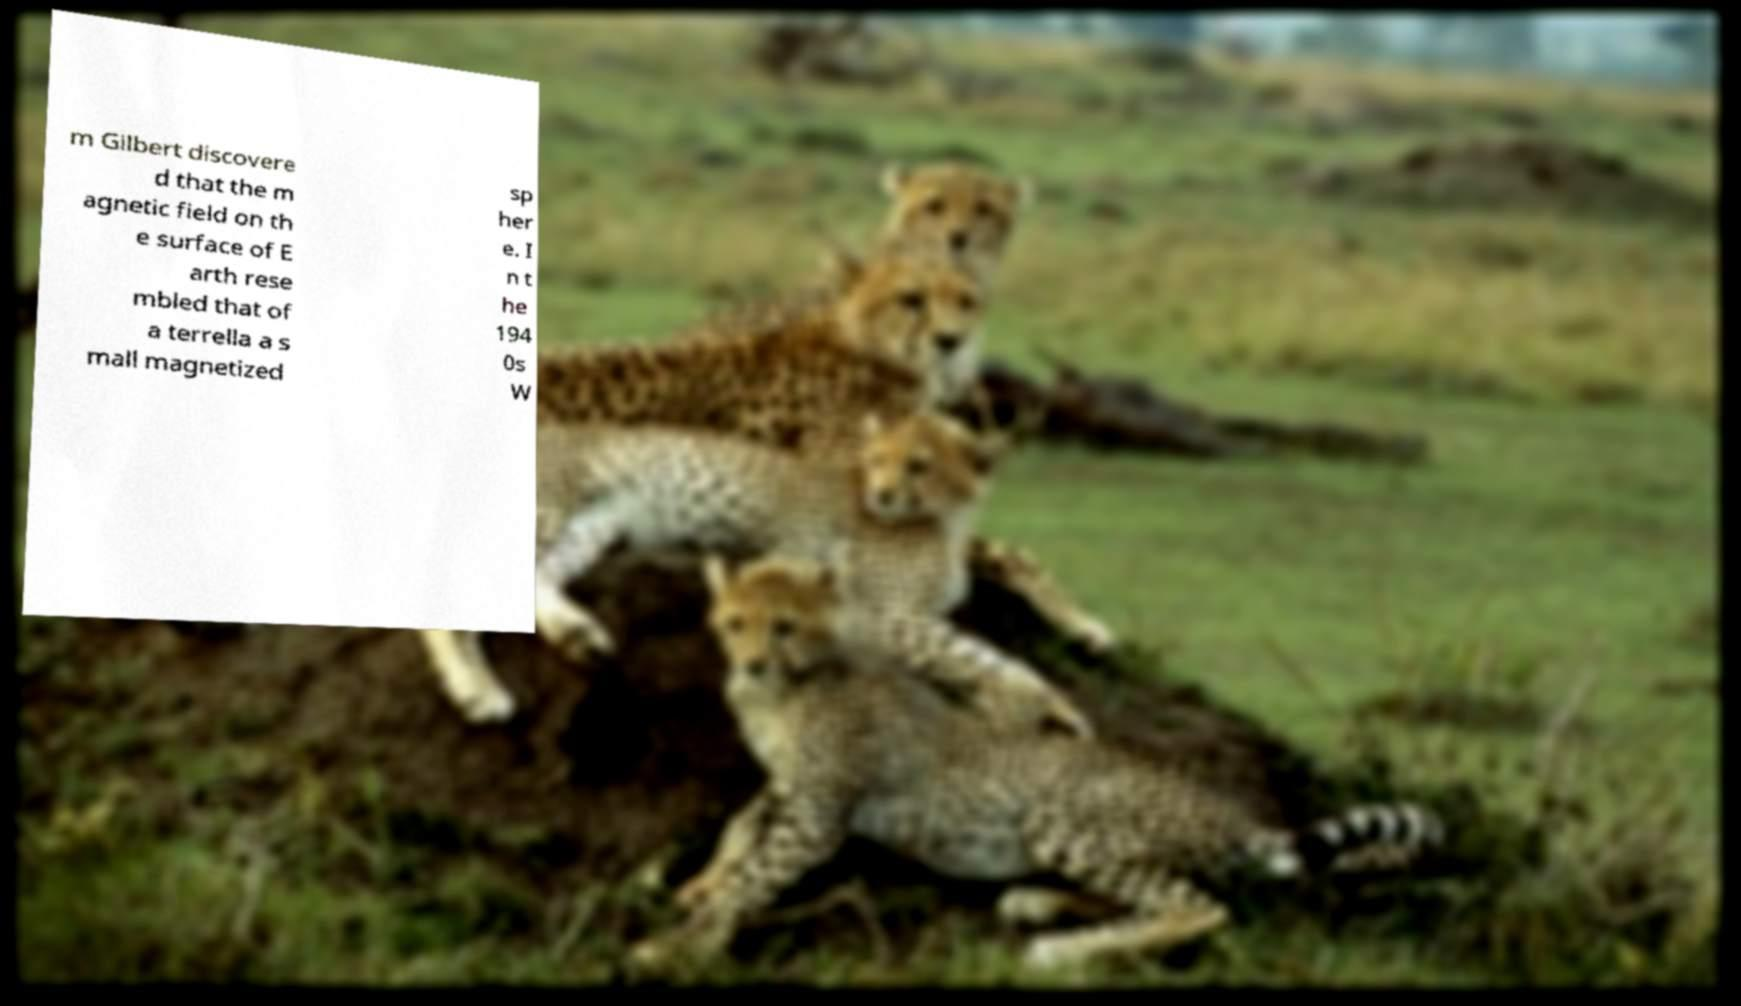There's text embedded in this image that I need extracted. Can you transcribe it verbatim? m Gilbert discovere d that the m agnetic field on th e surface of E arth rese mbled that of a terrella a s mall magnetized sp her e. I n t he 194 0s W 